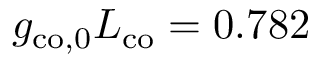Convert formula to latex. <formula><loc_0><loc_0><loc_500><loc_500>g _ { c o , 0 } L _ { c o } = 0 . 7 8 2</formula> 